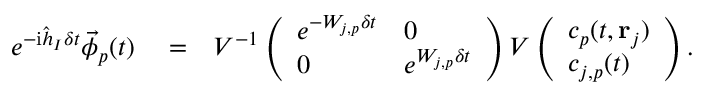Convert formula to latex. <formula><loc_0><loc_0><loc_500><loc_500>\begin{array} { r l r } { e ^ { - i \hat { h } _ { I } \delta t } \vec { \phi } _ { p } ( t ) } & = } & { V ^ { - 1 } \left ( \begin{array} { l l } { e ^ { - W _ { j , p } \delta t } } & { 0 } \\ { 0 } & { e ^ { W _ { j , p } \delta t } } \end{array} \right ) V \left ( \begin{array} { l } { c _ { p } ( t , { r } _ { j } ) } \\ { c _ { j , p } ( t ) } \end{array} \right ) . } \end{array}</formula> 